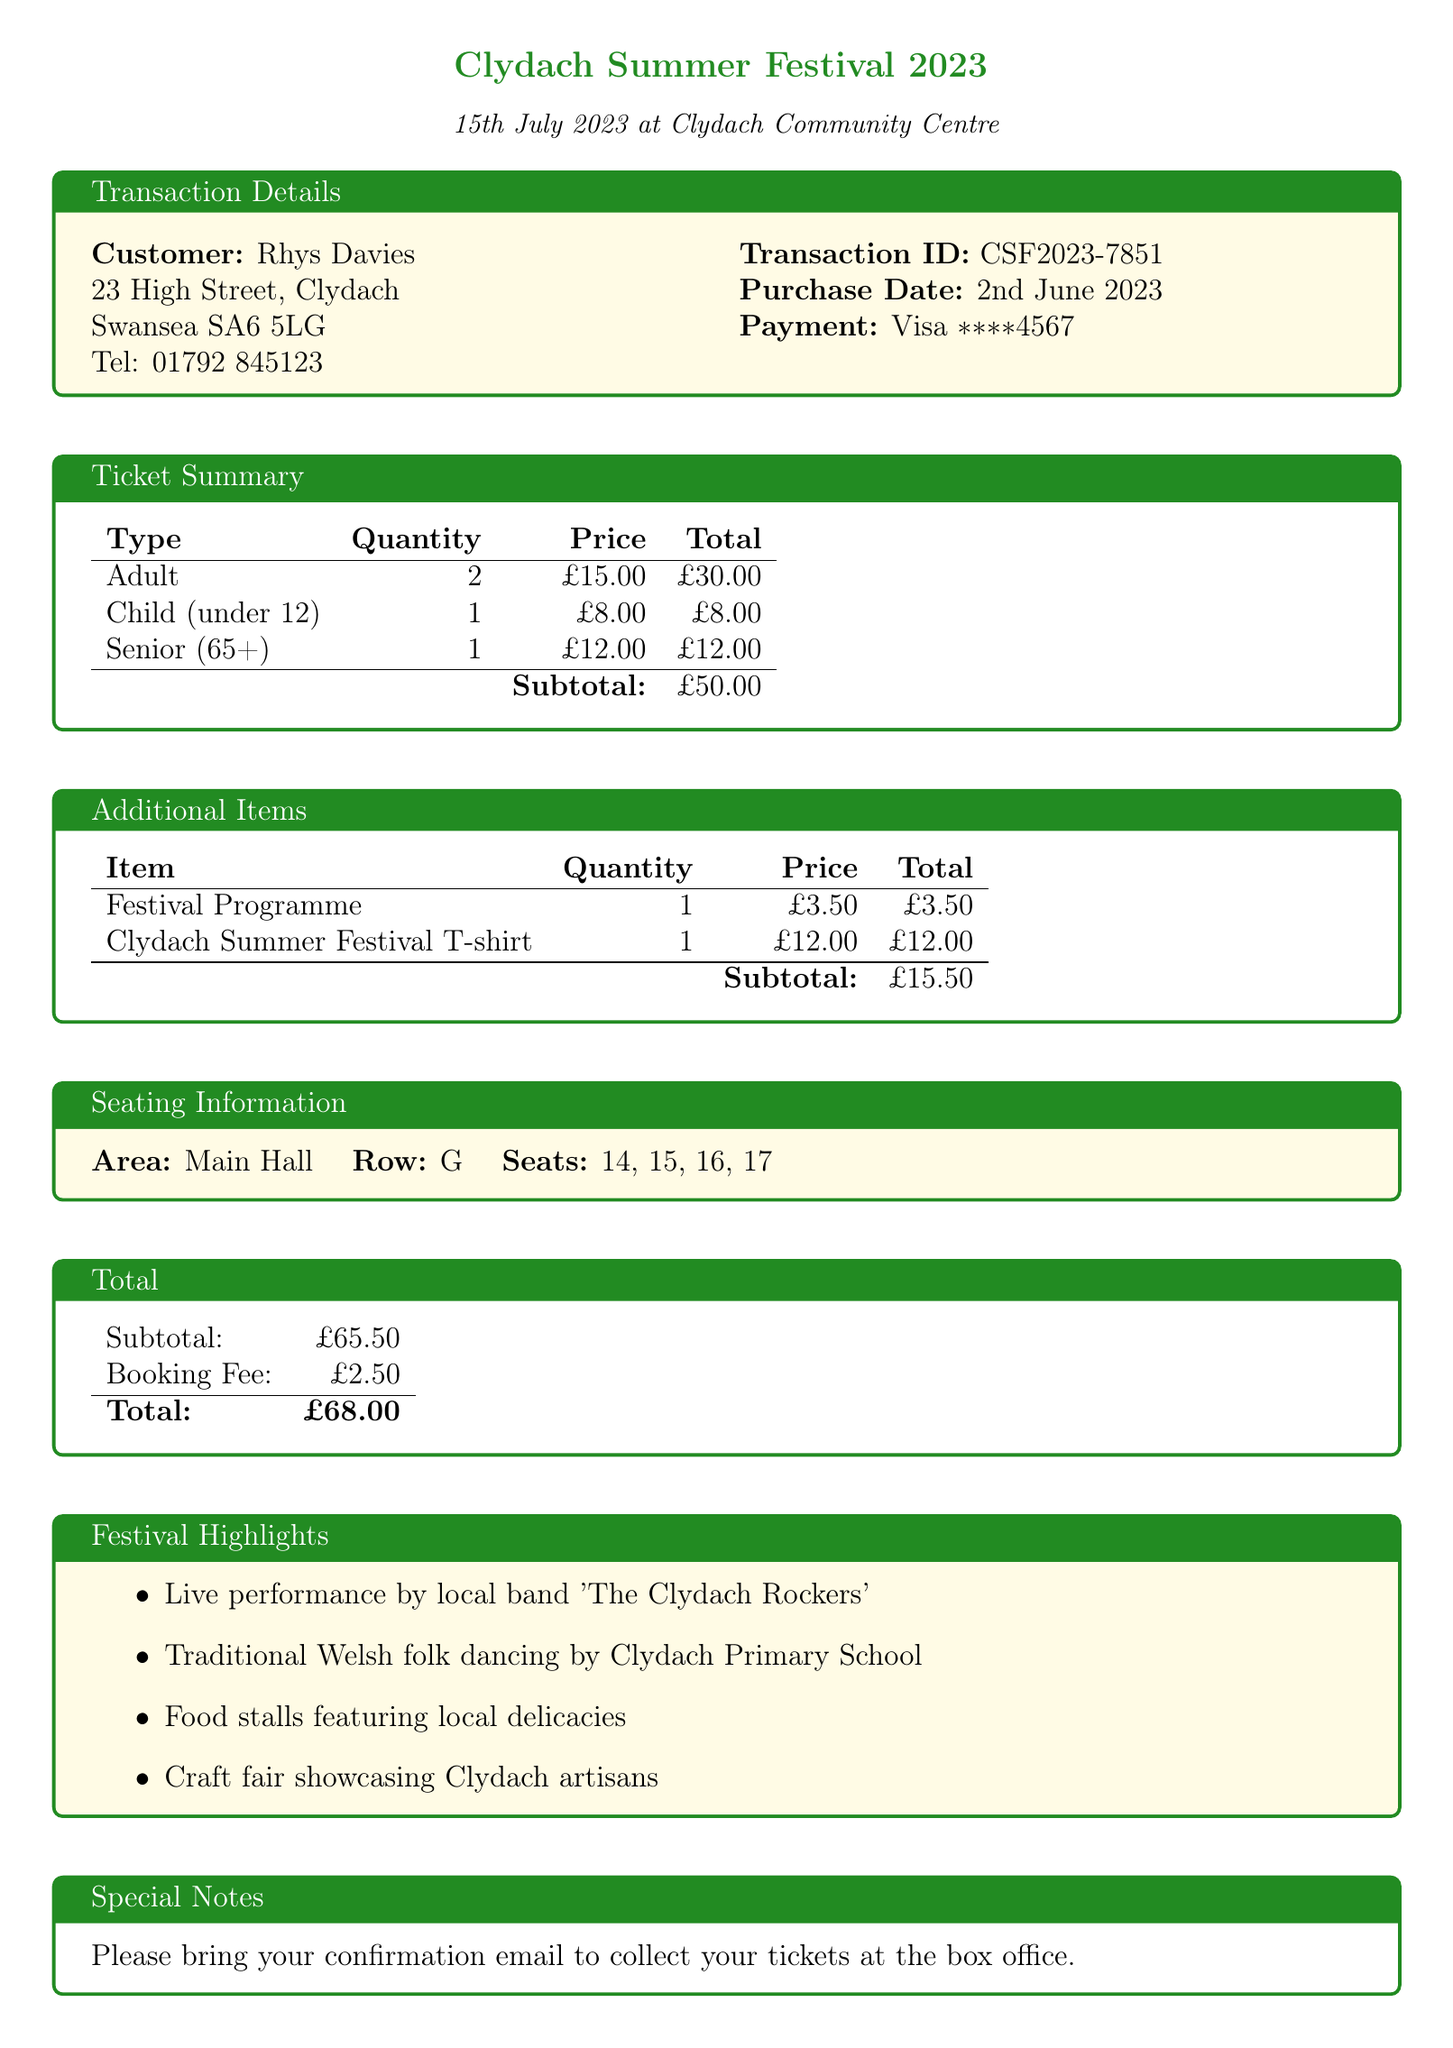What is the event name? The event name is clearly stated in the document as "Clydach Summer Festival 2023."
Answer: Clydach Summer Festival 2023 What is the total amount paid? The total amount paid is provided at the end of the payment summary as the final amount.
Answer: £68.00 Who is the customer? The customer's name is provided at the beginning of the transaction details.
Answer: Rhys Davies What is the date of the event? The date of the event is mentioned in the document, which specifies when the festival will take place.
Answer: 15th July 2023 How many adult tickets were purchased? The quantity of adult tickets is detailed in the ticket summary of the document.
Answer: 2 What is the booking fee? The booking fee is explicitly mentioned in the total section of the document.
Answer: £2.50 What is the seating area? The seating area is listed in the seating information section of the document.
Answer: Main Hall What items were purchased in addition to tickets? The document lists additional items found in the additional items section.
Answer: Festival Programme, Clydach Summer Festival T-shirt What is the transaction ID? The transaction ID is a unique identifier provided in the transaction details section.
Answer: CSF2023-7851 